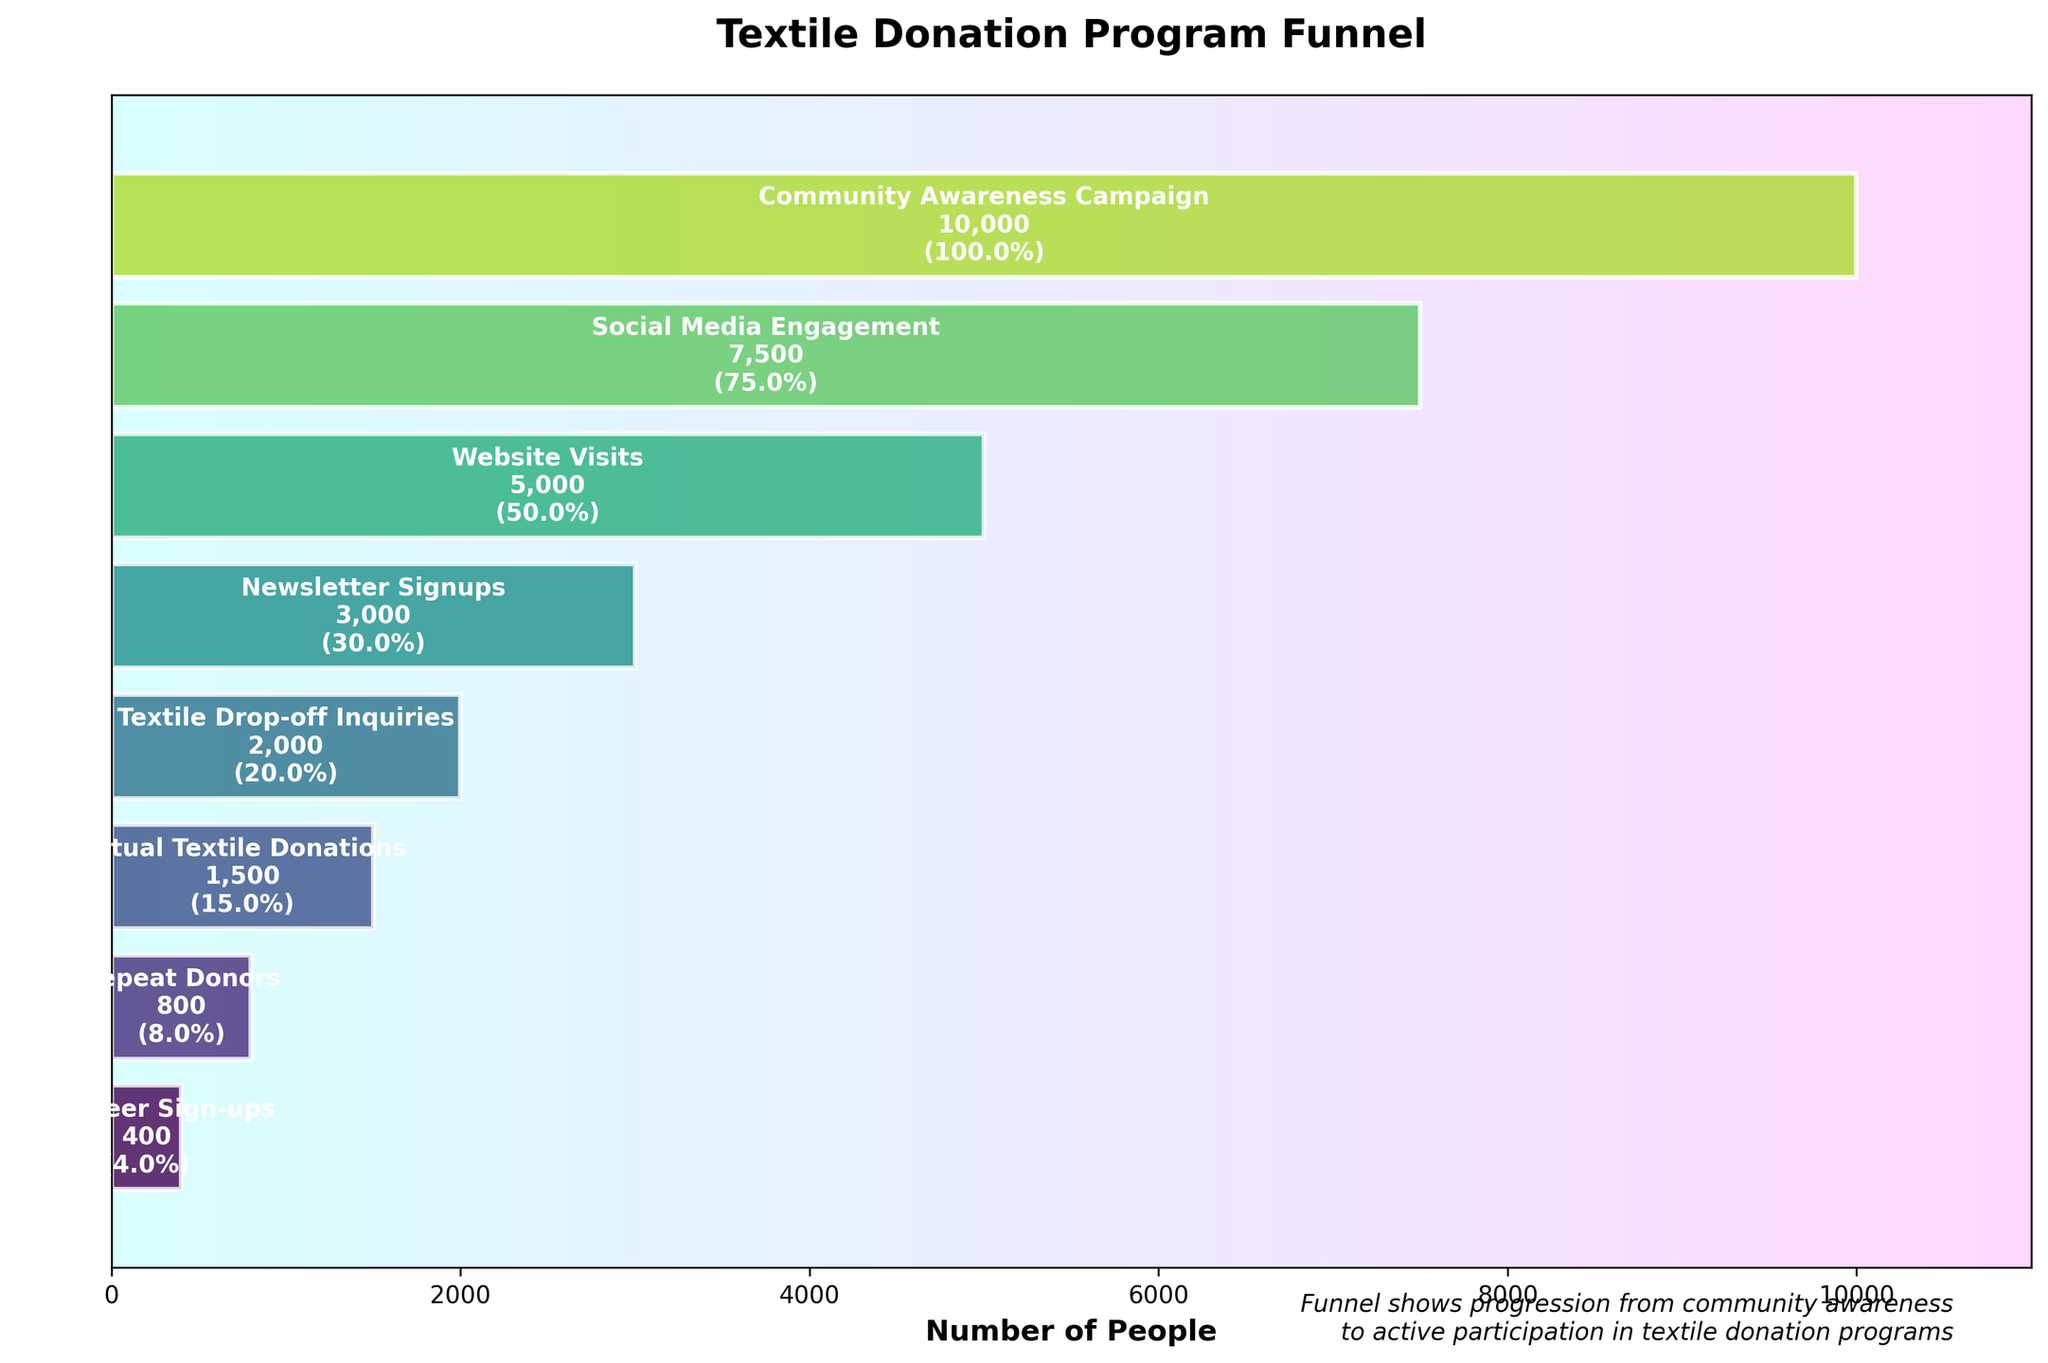What is the title of the funnel chart? The title is usually displayed at the top of the chart. In this case, the title reads "Textile Donation Program Funnel".
Answer: "Textile Donation Program Funnel" How many stages are depicted in the funnel chart? The stages are shown as different horizontal bars. By counting them, we find there are eight stages.
Answer: Eight Which stage has the highest number of people and what is that number? The width of the bar indicates the number of people. The widest bar is at the "Community Awareness Campaign" stage with 10,000 people.
Answer: "Community Awareness Campaign", 10,000 How many people actually donated textiles? The "Actual Textile Donations" stage represents the number of people who donated textiles. The bar indicates there are 1,500 people at this stage.
Answer: 1,500 What is the approximate percentage decrease from Community Awareness Campaign to Social Media Engagement? From the chart, Community Awareness has 10,000 people, and Social Media Engagement has 7,500 people. The decrease is (10,000 - 7,500) / 10,000 * 100 = 25%.
Answer: 25% How many people who signed up for newsletters eventually made actual textile donations? The number of people at the "Newsletter Signups" stage is 3,000, and the number making "Actual Textile Donations" is 1,500. Therefore, the number of people is 1,500.
Answer: 1,500 What is the ratio of volunteer sign-ups to repeat donors? The number of Volunteer Sign-ups is 400 and Repeat Donors is 800. The ratio is 400 / 800 = 0.5.
Answer: 0.5 Which stage shows the largest drop in the number of people compared to the previous stage? Comparing the differences between each consecutive stage: (10000 to 7500, 7500 to 5000, 5000 to 3000, 3000 to 2000, 2000 to 1500, 1500 to 800, 800 to 400), the largest drop is from Community Awareness (10,000) to Social Media Engagement (7,500), a drop of 2,500.
Answer: From Community Awareness to Social Media Engagement How many more people visited the website compared to those who inquired about textile drop-offs? The number of Website Visits is 5,000 and Textile Drop-off Inquiries is 2,000. The difference is 5,000 - 2,000 = 3,000.
Answer: 3,000 What is the ratio of actual textile donations to the initial community awareness? The number of Actual Textile Donations is 1,500 and Community Awareness is 10,000. The ratio is 1,500 / 10,000 = 0.15.
Answer: 0.15 